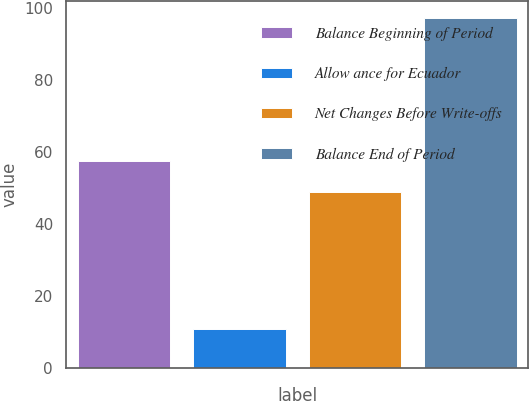Convert chart to OTSL. <chart><loc_0><loc_0><loc_500><loc_500><bar_chart><fcel>Balance Beginning of Period<fcel>Allow ance for Ecuador<fcel>Net Changes Before Write-offs<fcel>Balance End of Period<nl><fcel>57.6<fcel>11<fcel>49<fcel>97<nl></chart> 